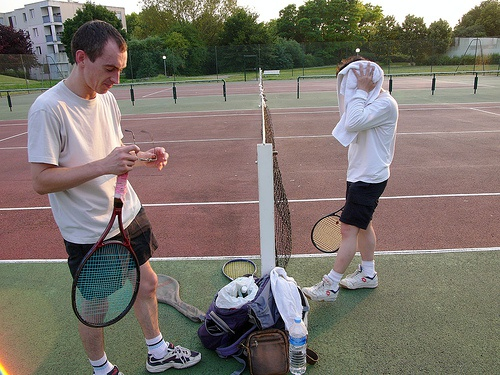Describe the objects in this image and their specific colors. I can see people in white, darkgray, gray, and black tones, people in white, darkgray, black, and gray tones, tennis racket in white, black, gray, teal, and maroon tones, backpack in white, black, lavender, navy, and gray tones, and handbag in white, black, brown, and maroon tones in this image. 